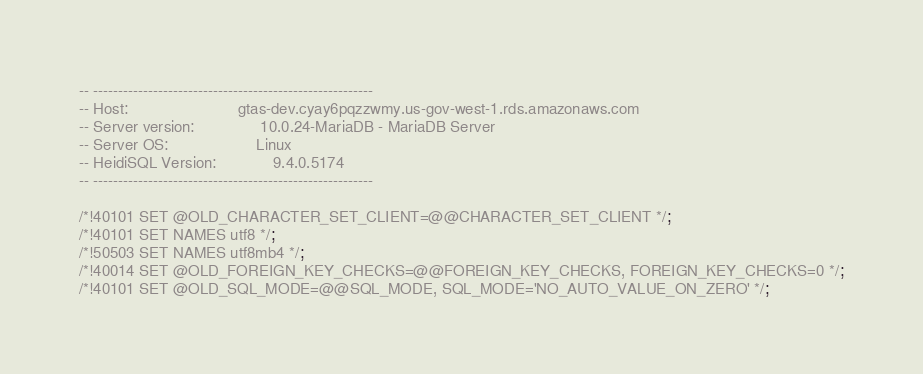Convert code to text. <code><loc_0><loc_0><loc_500><loc_500><_SQL_>-- --------------------------------------------------------
-- Host:                         gtas-dev.cyay6pqzzwmy.us-gov-west-1.rds.amazonaws.com
-- Server version:               10.0.24-MariaDB - MariaDB Server
-- Server OS:                    Linux
-- HeidiSQL Version:             9.4.0.5174
-- --------------------------------------------------------

/*!40101 SET @OLD_CHARACTER_SET_CLIENT=@@CHARACTER_SET_CLIENT */;
/*!40101 SET NAMES utf8 */;
/*!50503 SET NAMES utf8mb4 */;
/*!40014 SET @OLD_FOREIGN_KEY_CHECKS=@@FOREIGN_KEY_CHECKS, FOREIGN_KEY_CHECKS=0 */;
/*!40101 SET @OLD_SQL_MODE=@@SQL_MODE, SQL_MODE='NO_AUTO_VALUE_ON_ZERO' */;</code> 